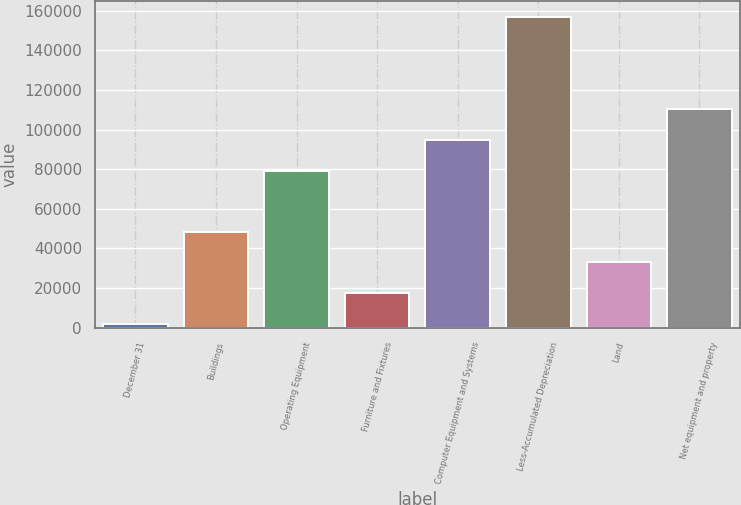<chart> <loc_0><loc_0><loc_500><loc_500><bar_chart><fcel>December 31<fcel>Buildings<fcel>Operating Equipment<fcel>Furniture and Fixtures<fcel>Computer Equipment and Systems<fcel>Less-Accumulated Depreciation<fcel>Land<fcel>Net equipment and property<nl><fcel>2014<fcel>48491.8<fcel>79235<fcel>17506.6<fcel>94727.6<fcel>156940<fcel>32999.2<fcel>110220<nl></chart> 